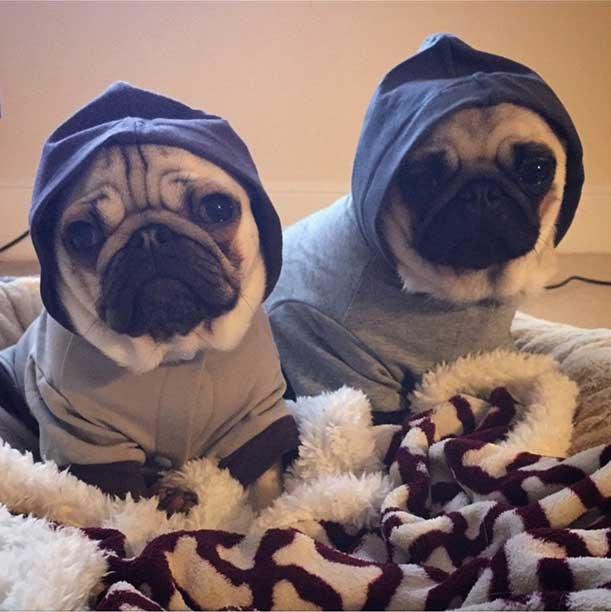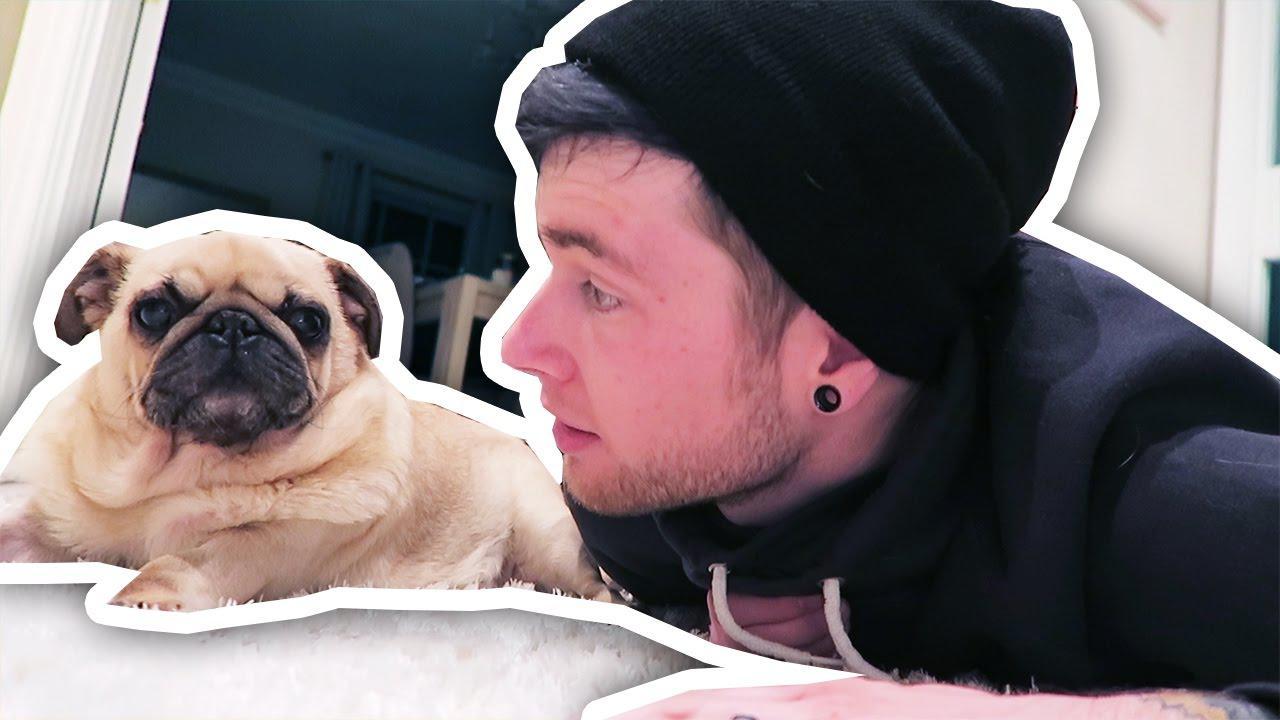The first image is the image on the left, the second image is the image on the right. For the images shown, is this caption "A dog is wearing something on its head." true? Answer yes or no. Yes. The first image is the image on the left, the second image is the image on the right. Evaluate the accuracy of this statement regarding the images: "At least one image shows a human behind the dog hugging it.". Is it true? Answer yes or no. No. 